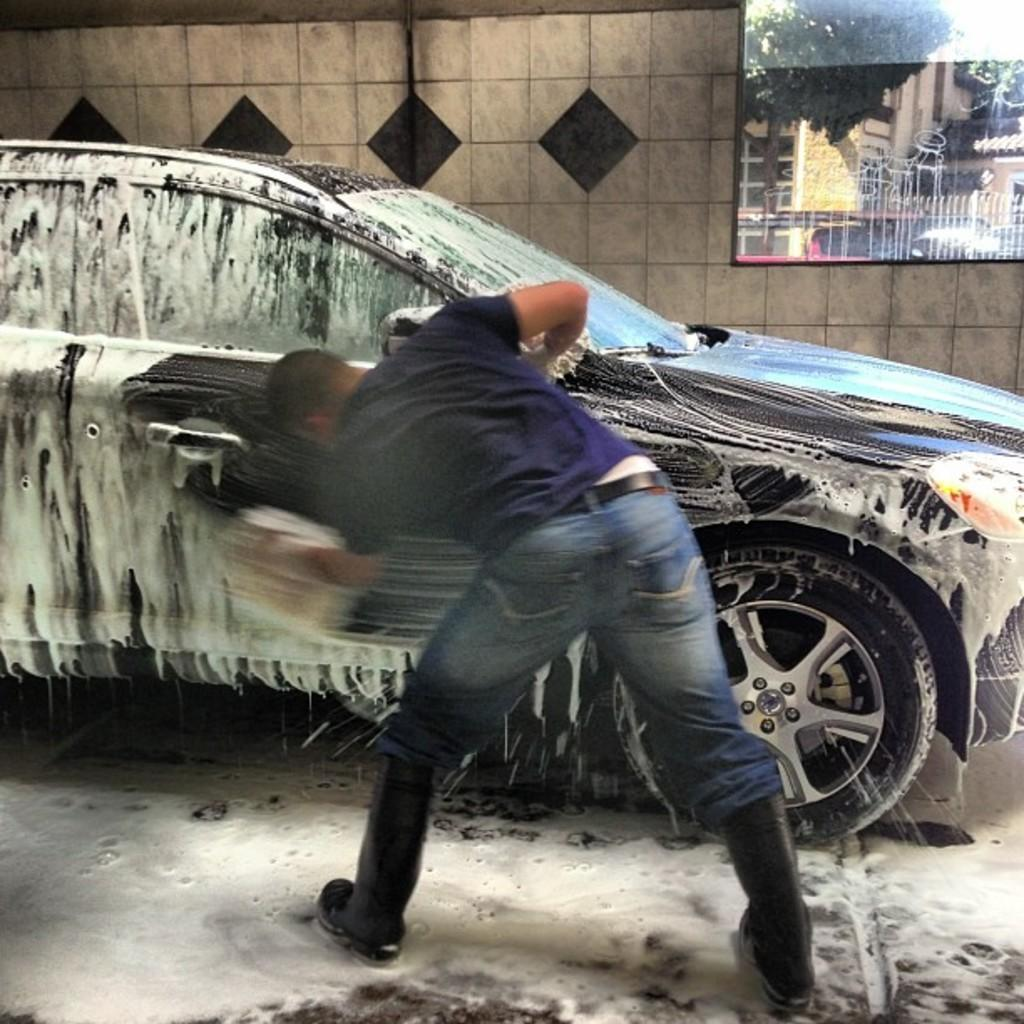What is the person in the image doing? The person is cleaning a car. Where is the person standing while cleaning the car? The person is standing on the floor. What can be seen behind the car in the image? There is a wall behind the car, and the wall has a window. What is visible through the window in the image? Buildings and trees are visible through the window. What type of meat is the person using to clean the car in the image? There is no meat present in the image; the person is using a cleaning tool or cloth to clean the car. 